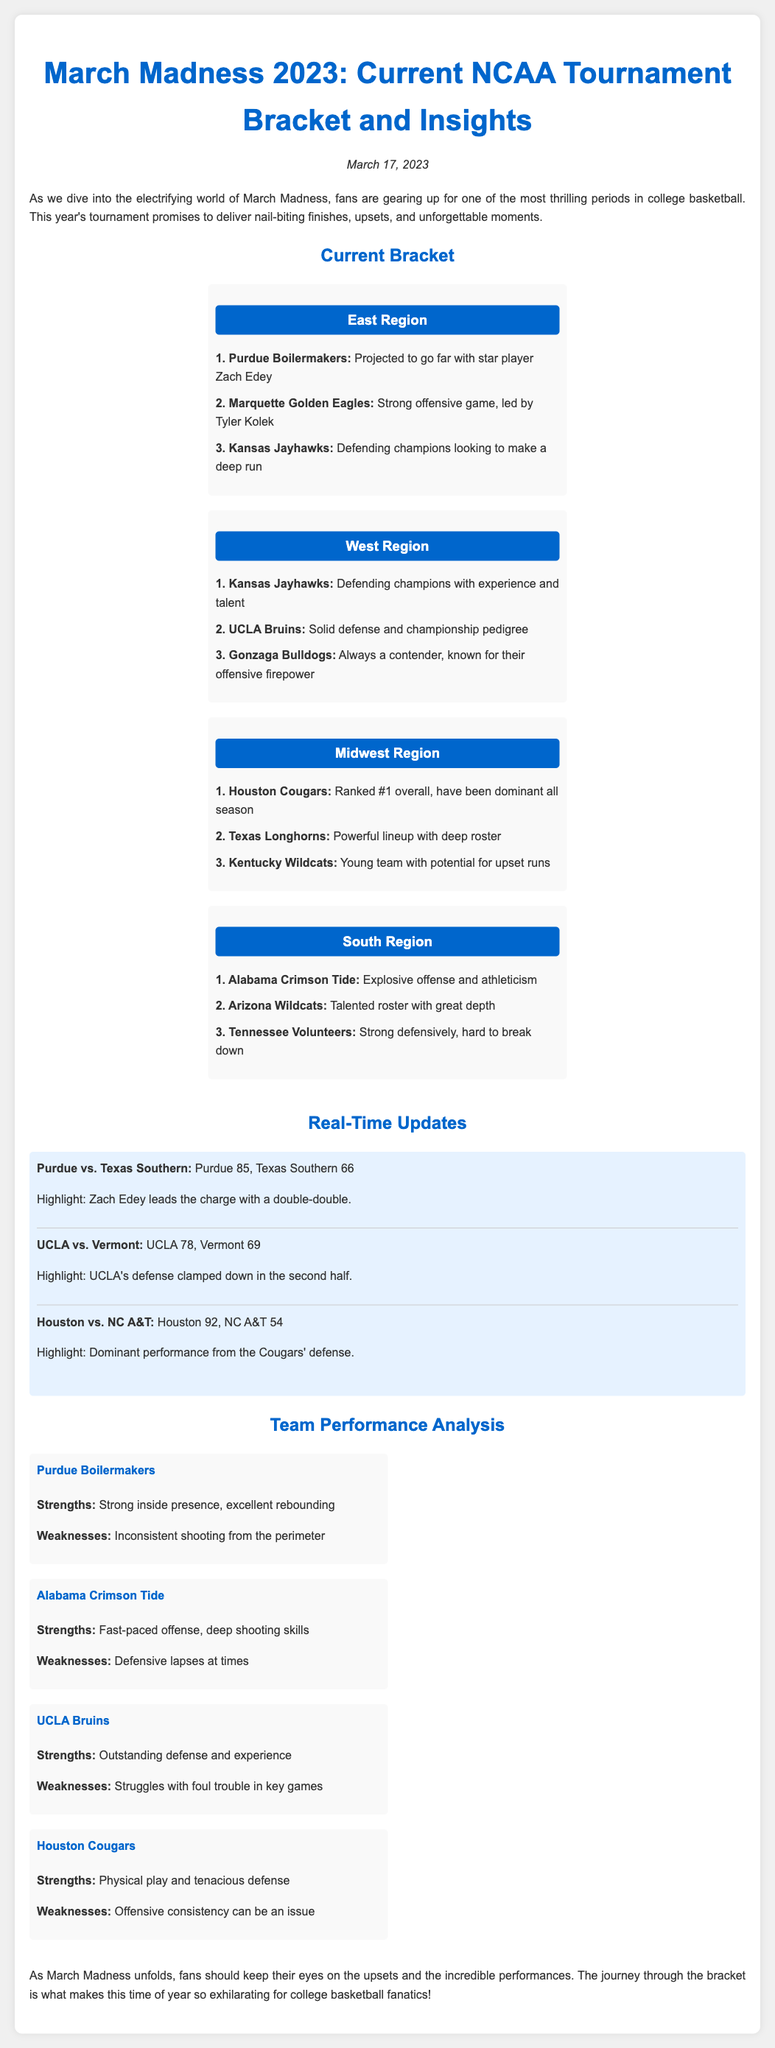What date is mentioned in the document? The date stated in the document is March 17, 2023.
Answer: March 17, 2023 Which team is projected to go far with star player Zach Edey? The Purdue Boilermakers are noted for having star player Zach Edey and a strong projection to go far in the tournament.
Answer: Purdue Boilermakers What was the score of the Houston vs. NC A&T game? The score reported for the game between Houston and NC A&T is 92 to 54.
Answer: 92, 54 What is a strength of the Alabama Crimson Tide? A highlighted strength of the Alabama Crimson Tide is their fast-paced offense and deep shooting skills.
Answer: Fast-paced offense How many regions are listed in the current bracket? Four regions: East, West, Midwest, and South are included in the current bracket.
Answer: Four What is a weakness for the Purdue Boilermakers? An inconsistency in shooting from the perimeter is identified as a weakness for the Purdue Boilermakers.
Answer: Inconsistent shooting Which team had a dominant performance according to the updates? The Houston Cougars are noted for their dominant performance, especially in defense.
Answer: Houston Cougars What is emphasized as exciting about March Madness in the document? The document emphasizes the upsets and incredible performances as exciting elements of March Madness.
Answer: Upsets and incredible performances 